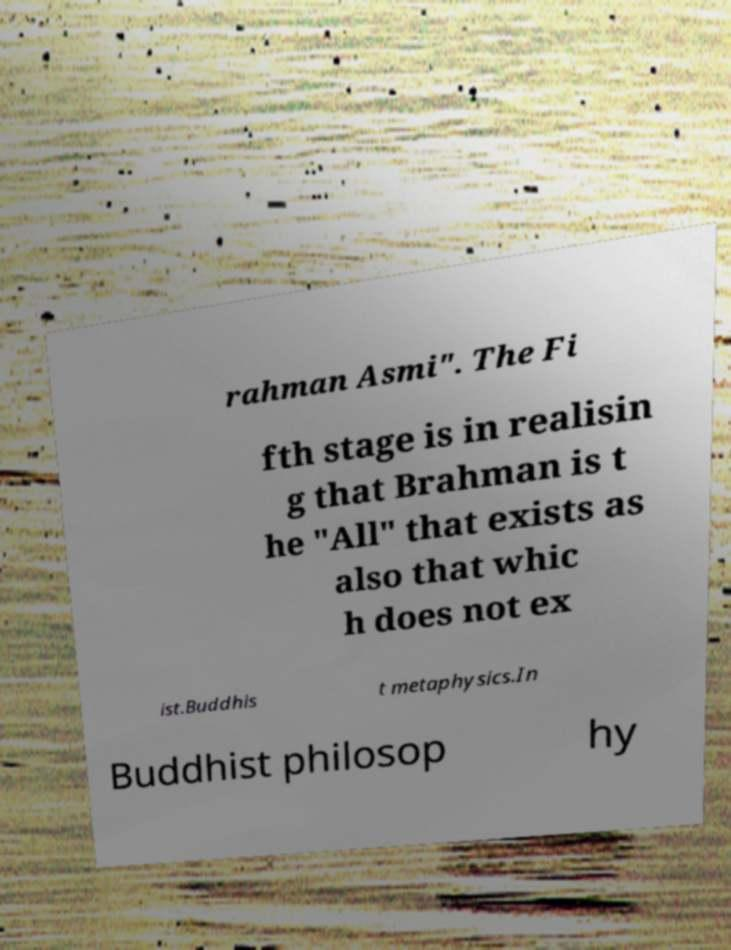Could you assist in decoding the text presented in this image and type it out clearly? rahman Asmi". The Fi fth stage is in realisin g that Brahman is t he "All" that exists as also that whic h does not ex ist.Buddhis t metaphysics.In Buddhist philosop hy 